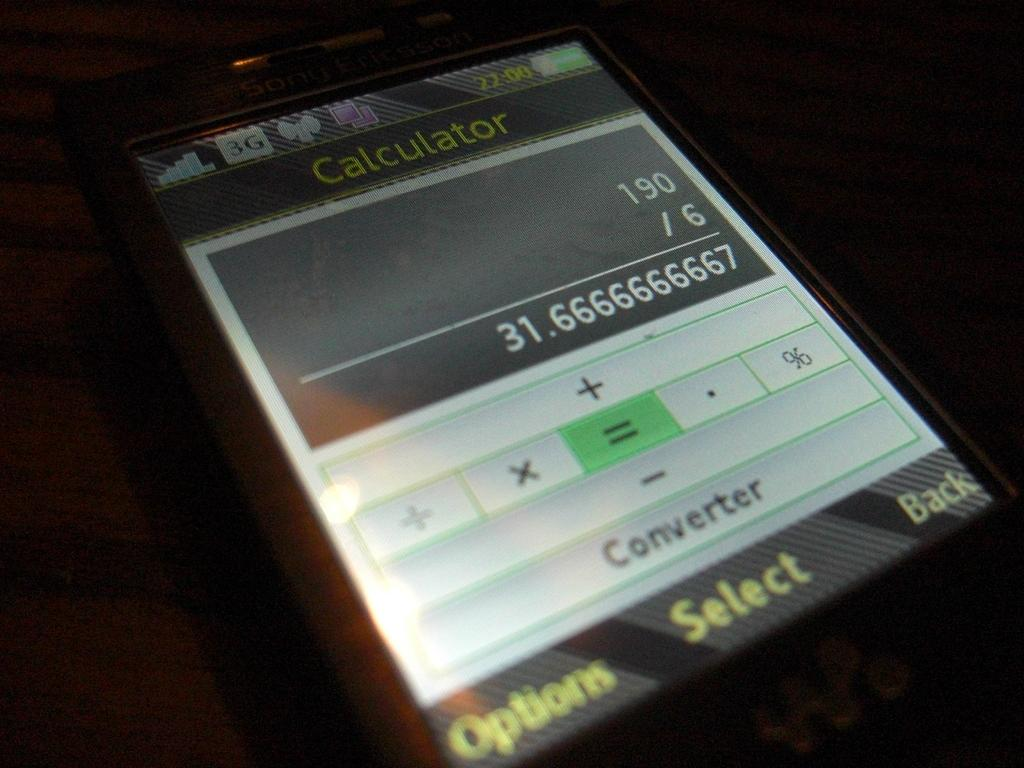<image>
Describe the image concisely. Phone screen that has the calculator open and the option button on the bottom left. 